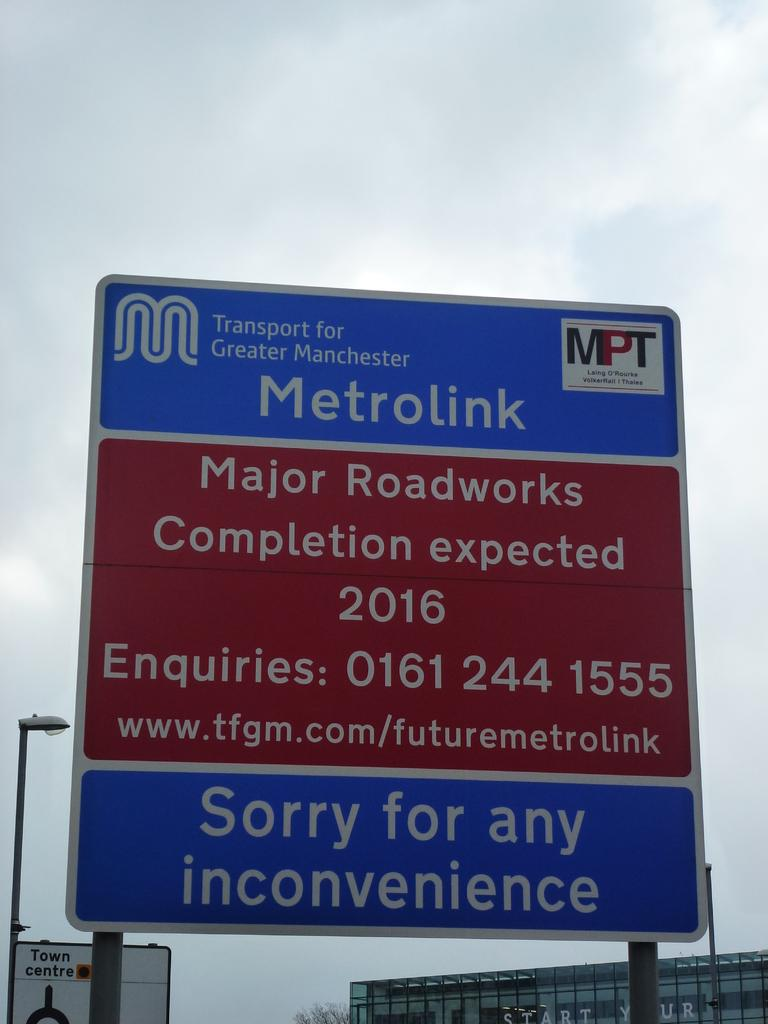Provide a one-sentence caption for the provided image. A blue and red sign explaining the Metrolink project on a sunny day. 